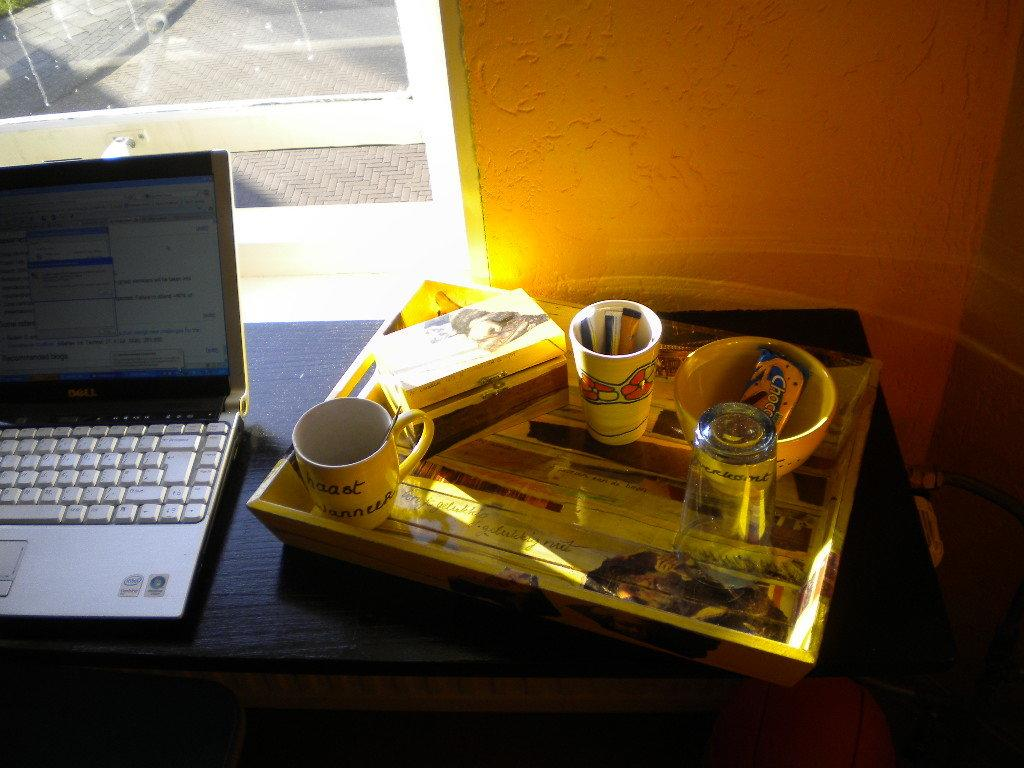What piece of furniture is in the image? There is a table in the image. What electronic device is on the table? A laptop is present on the table. What other items can be seen on the table? There is a tray, glasses, a mug, a bowl, and a box on the table. What can be seen in the background of the image? There is a wall and a window in the background of the image. How does the road lead to the basket in the image? There is no road or basket present in the image. 